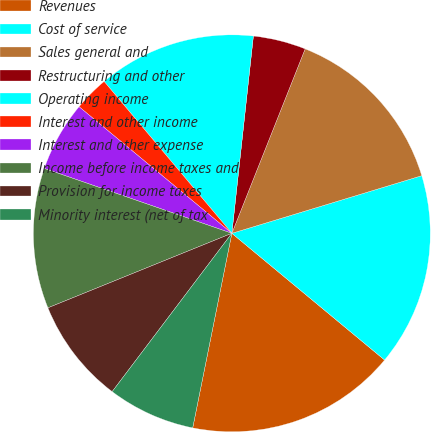<chart> <loc_0><loc_0><loc_500><loc_500><pie_chart><fcel>Revenues<fcel>Cost of service<fcel>Sales general and<fcel>Restructuring and other<fcel>Operating income<fcel>Interest and other income<fcel>Interest and other expense<fcel>Income before income taxes and<fcel>Provision for income taxes<fcel>Minority interest (net of tax<nl><fcel>17.14%<fcel>15.71%<fcel>14.29%<fcel>4.29%<fcel>12.86%<fcel>2.86%<fcel>5.71%<fcel>11.43%<fcel>8.57%<fcel>7.14%<nl></chart> 